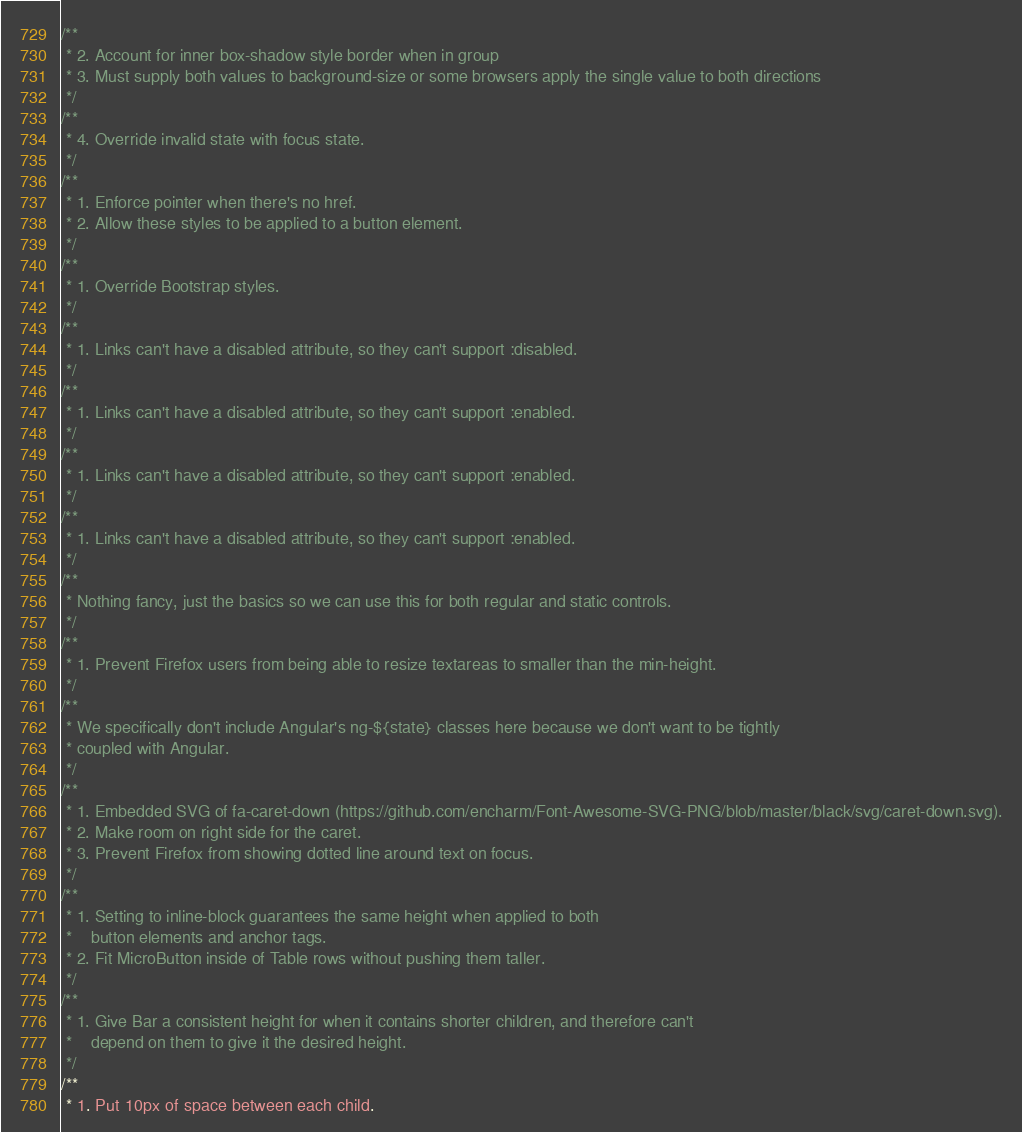<code> <loc_0><loc_0><loc_500><loc_500><_CSS_>/**
 * 2. Account for inner box-shadow style border when in group
 * 3. Must supply both values to background-size or some browsers apply the single value to both directions
 */
/**
 * 4. Override invalid state with focus state.
 */
/**
 * 1. Enforce pointer when there's no href.
 * 2. Allow these styles to be applied to a button element.
 */
/**
 * 1. Override Bootstrap styles.
 */
/**
 * 1. Links can't have a disabled attribute, so they can't support :disabled.
 */
/**
 * 1. Links can't have a disabled attribute, so they can't support :enabled.
 */
/**
 * 1. Links can't have a disabled attribute, so they can't support :enabled.
 */
/**
 * 1. Links can't have a disabled attribute, so they can't support :enabled.
 */
/**
 * Nothing fancy, just the basics so we can use this for both regular and static controls.
 */
/**
 * 1. Prevent Firefox users from being able to resize textareas to smaller than the min-height.
 */
/**
 * We specifically don't include Angular's ng-${state} classes here because we don't want to be tightly
 * coupled with Angular.
 */
/**
 * 1. Embedded SVG of fa-caret-down (https://github.com/encharm/Font-Awesome-SVG-PNG/blob/master/black/svg/caret-down.svg).
 * 2. Make room on right side for the caret.
 * 3. Prevent Firefox from showing dotted line around text on focus.
 */
/**
 * 1. Setting to inline-block guarantees the same height when applied to both
 *    button elements and anchor tags.
 * 2. Fit MicroButton inside of Table rows without pushing them taller.
 */
/**
 * 1. Give Bar a consistent height for when it contains shorter children, and therefore can't
 *    depend on them to give it the desired height.
 */
/**
 * 1. Put 10px of space between each child.</code> 